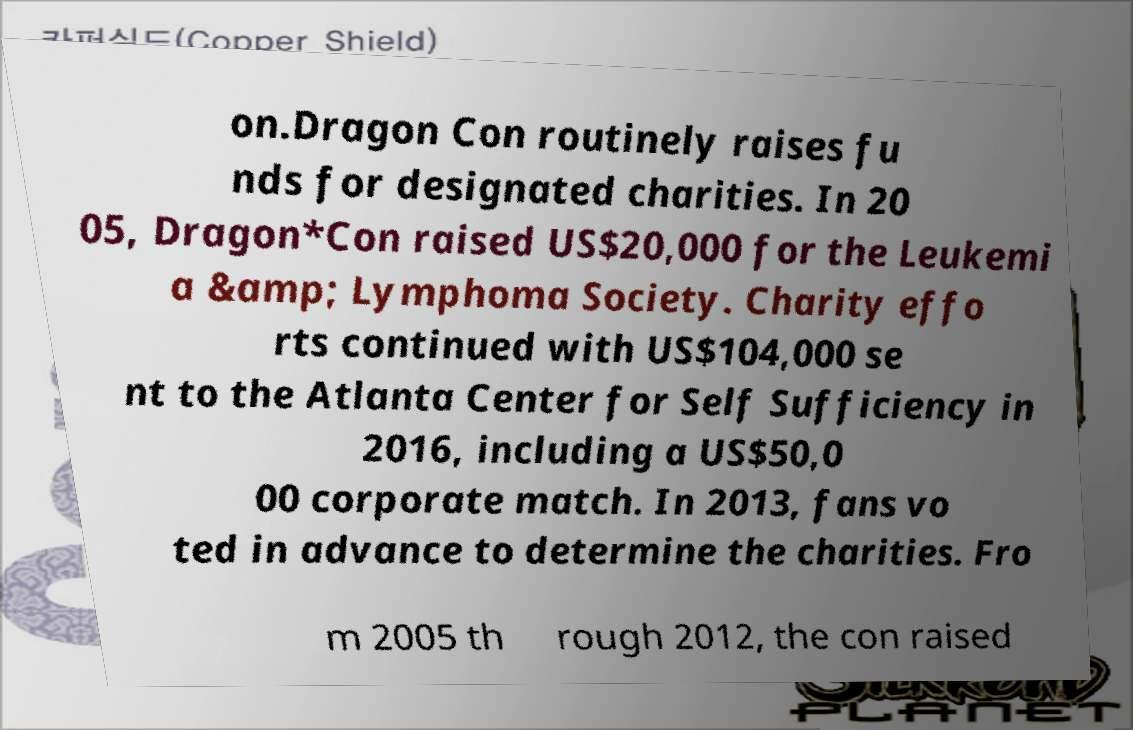Can you read and provide the text displayed in the image?This photo seems to have some interesting text. Can you extract and type it out for me? on.Dragon Con routinely raises fu nds for designated charities. In 20 05, Dragon*Con raised US$20,000 for the Leukemi a &amp; Lymphoma Society. Charity effo rts continued with US$104,000 se nt to the Atlanta Center for Self Sufficiency in 2016, including a US$50,0 00 corporate match. In 2013, fans vo ted in advance to determine the charities. Fro m 2005 th rough 2012, the con raised 